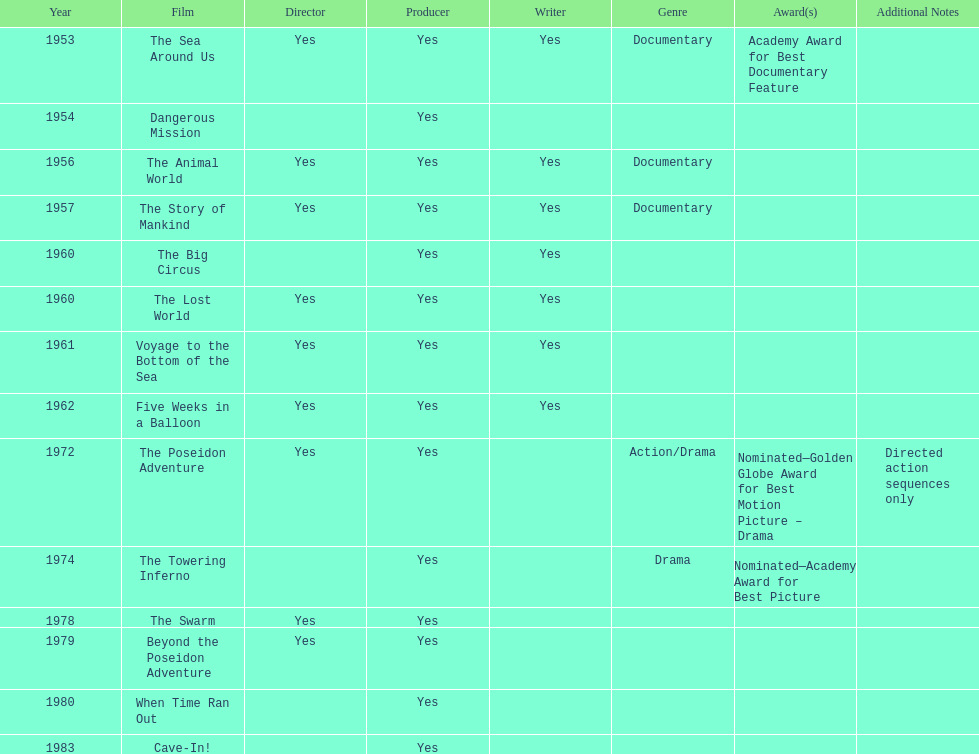How many films did irwin allen direct, produce and write? 6. 